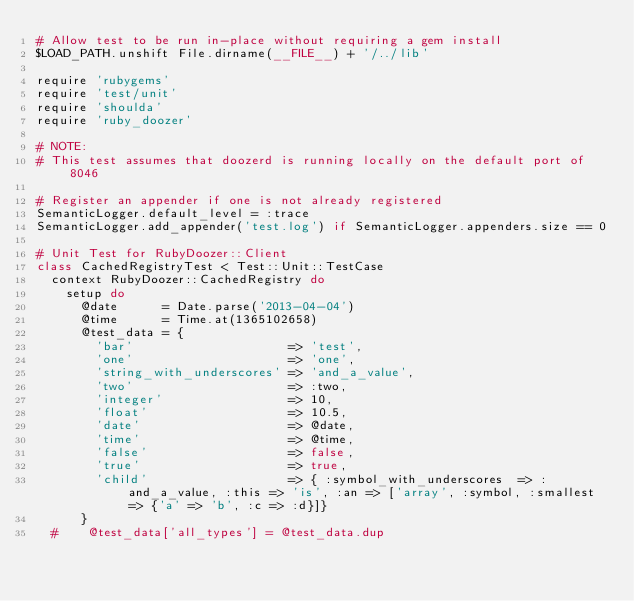<code> <loc_0><loc_0><loc_500><loc_500><_Ruby_># Allow test to be run in-place without requiring a gem install
$LOAD_PATH.unshift File.dirname(__FILE__) + '/../lib'

require 'rubygems'
require 'test/unit'
require 'shoulda'
require 'ruby_doozer'

# NOTE:
# This test assumes that doozerd is running locally on the default port of 8046

# Register an appender if one is not already registered
SemanticLogger.default_level = :trace
SemanticLogger.add_appender('test.log') if SemanticLogger.appenders.size == 0

# Unit Test for RubyDoozer::Client
class CachedRegistryTest < Test::Unit::TestCase
  context RubyDoozer::CachedRegistry do
    setup do
      @date      = Date.parse('2013-04-04')
      @time      = Time.at(1365102658)
      @test_data = {
        'bar'                     => 'test',
        'one'                     => 'one',
        'string_with_underscores' => 'and_a_value',
        'two'                     => :two,
        'integer'                 => 10,
        'float'                   => 10.5,
        'date'                    => @date,
        'time'                    => @time,
        'false'                   => false,
        'true'                    => true,
        'child'                   => { :symbol_with_underscores  => :and_a_value, :this => 'is', :an => ['array', :symbol, :smallest => {'a' => 'b', :c => :d}]}
      }
  #    @test_data['all_types'] = @test_data.dup</code> 